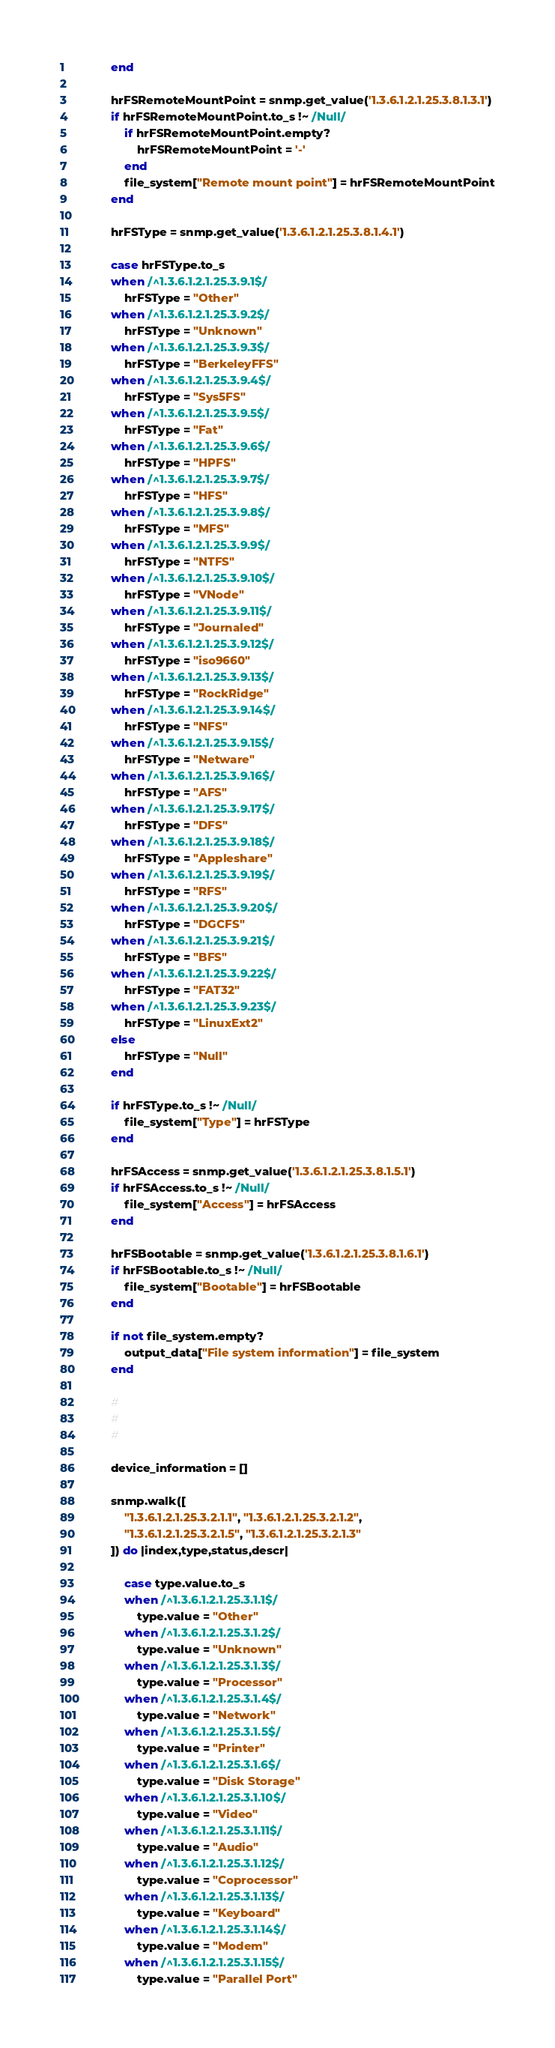<code> <loc_0><loc_0><loc_500><loc_500><_Ruby_>			end

			hrFSRemoteMountPoint = snmp.get_value('1.3.6.1.2.1.25.3.8.1.3.1')
			if hrFSRemoteMountPoint.to_s !~ /Null/
				if hrFSRemoteMountPoint.empty?
					hrFSRemoteMountPoint = '-'
				end
				file_system["Remote mount point"] = hrFSRemoteMountPoint
			end

			hrFSType = snmp.get_value('1.3.6.1.2.1.25.3.8.1.4.1')

			case hrFSType.to_s
			when /^1.3.6.1.2.1.25.3.9.1$/
				hrFSType = "Other"
			when /^1.3.6.1.2.1.25.3.9.2$/
				hrFSType = "Unknown"
			when /^1.3.6.1.2.1.25.3.9.3$/
				hrFSType = "BerkeleyFFS"
			when /^1.3.6.1.2.1.25.3.9.4$/
				hrFSType = "Sys5FS"
			when /^1.3.6.1.2.1.25.3.9.5$/
				hrFSType = "Fat"
			when /^1.3.6.1.2.1.25.3.9.6$/
				hrFSType = "HPFS"
			when /^1.3.6.1.2.1.25.3.9.7$/
				hrFSType = "HFS"
			when /^1.3.6.1.2.1.25.3.9.8$/
				hrFSType = "MFS"
			when /^1.3.6.1.2.1.25.3.9.9$/
				hrFSType = "NTFS"
			when /^1.3.6.1.2.1.25.3.9.10$/
				hrFSType = "VNode"
			when /^1.3.6.1.2.1.25.3.9.11$/
				hrFSType = "Journaled"
			when /^1.3.6.1.2.1.25.3.9.12$/
				hrFSType = "iso9660"
			when /^1.3.6.1.2.1.25.3.9.13$/
				hrFSType = "RockRidge"
			when /^1.3.6.1.2.1.25.3.9.14$/
				hrFSType = "NFS"
			when /^1.3.6.1.2.1.25.3.9.15$/
				hrFSType = "Netware"
			when /^1.3.6.1.2.1.25.3.9.16$/
				hrFSType = "AFS"
			when /^1.3.6.1.2.1.25.3.9.17$/
				hrFSType = "DFS"
			when /^1.3.6.1.2.1.25.3.9.18$/
				hrFSType = "Appleshare"
			when /^1.3.6.1.2.1.25.3.9.19$/
				hrFSType = "RFS"
			when /^1.3.6.1.2.1.25.3.9.20$/
				hrFSType = "DGCFS"
			when /^1.3.6.1.2.1.25.3.9.21$/
				hrFSType = "BFS"
			when /^1.3.6.1.2.1.25.3.9.22$/
				hrFSType = "FAT32"
			when /^1.3.6.1.2.1.25.3.9.23$/
				hrFSType = "LinuxExt2"
			else
				hrFSType = "Null"
			end

			if hrFSType.to_s !~ /Null/
				file_system["Type"] = hrFSType
			end

			hrFSAccess = snmp.get_value('1.3.6.1.2.1.25.3.8.1.5.1')
			if hrFSAccess.to_s !~ /Null/
				file_system["Access"] = hrFSAccess
			end

			hrFSBootable = snmp.get_value('1.3.6.1.2.1.25.3.8.1.6.1')
			if hrFSBootable.to_s !~ /Null/
				file_system["Bootable"] = hrFSBootable
			end

			if not file_system.empty?
				output_data["File system information"] = file_system
			end

			#
			#
			#

			device_information = []

			snmp.walk([
				"1.3.6.1.2.1.25.3.2.1.1", "1.3.6.1.2.1.25.3.2.1.2",
				"1.3.6.1.2.1.25.3.2.1.5", "1.3.6.1.2.1.25.3.2.1.3"
			]) do |index,type,status,descr|

				case type.value.to_s
				when /^1.3.6.1.2.1.25.3.1.1$/
					type.value = "Other"
				when /^1.3.6.1.2.1.25.3.1.2$/
					type.value = "Unknown"
				when /^1.3.6.1.2.1.25.3.1.3$/
					type.value = "Processor"
				when /^1.3.6.1.2.1.25.3.1.4$/
					type.value = "Network"
				when /^1.3.6.1.2.1.25.3.1.5$/
					type.value = "Printer"
				when /^1.3.6.1.2.1.25.3.1.6$/
					type.value = "Disk Storage"
				when /^1.3.6.1.2.1.25.3.1.10$/
					type.value = "Video"
				when /^1.3.6.1.2.1.25.3.1.11$/
					type.value = "Audio"
				when /^1.3.6.1.2.1.25.3.1.12$/
					type.value = "Coprocessor"
				when /^1.3.6.1.2.1.25.3.1.13$/
					type.value = "Keyboard"
				when /^1.3.6.1.2.1.25.3.1.14$/
					type.value = "Modem"
				when /^1.3.6.1.2.1.25.3.1.15$/
					type.value = "Parallel Port"</code> 